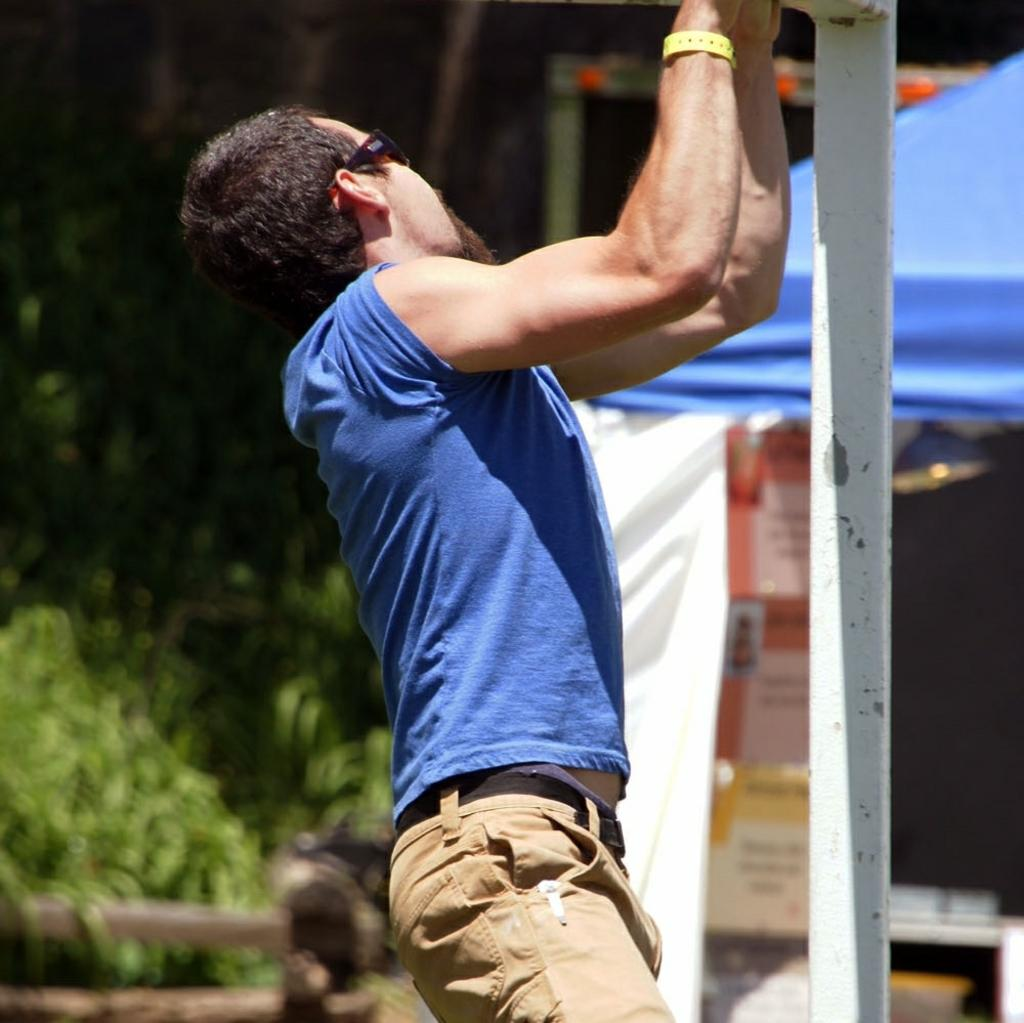What is the main subject of the image? There is a man standing in the image. What can be seen in the background of the image? There are green color plants in the background of the image. Can you describe the color tint of the image? There is a blue color tint in the image. How many vases are visible in the image? There are no vases present in the image. What type of berry can be seen growing on the plants in the image? There are no berries visible in the image, as the plants are not specified as berry-producing plants. Is there a yak in the image? There is no yak present in the image. 